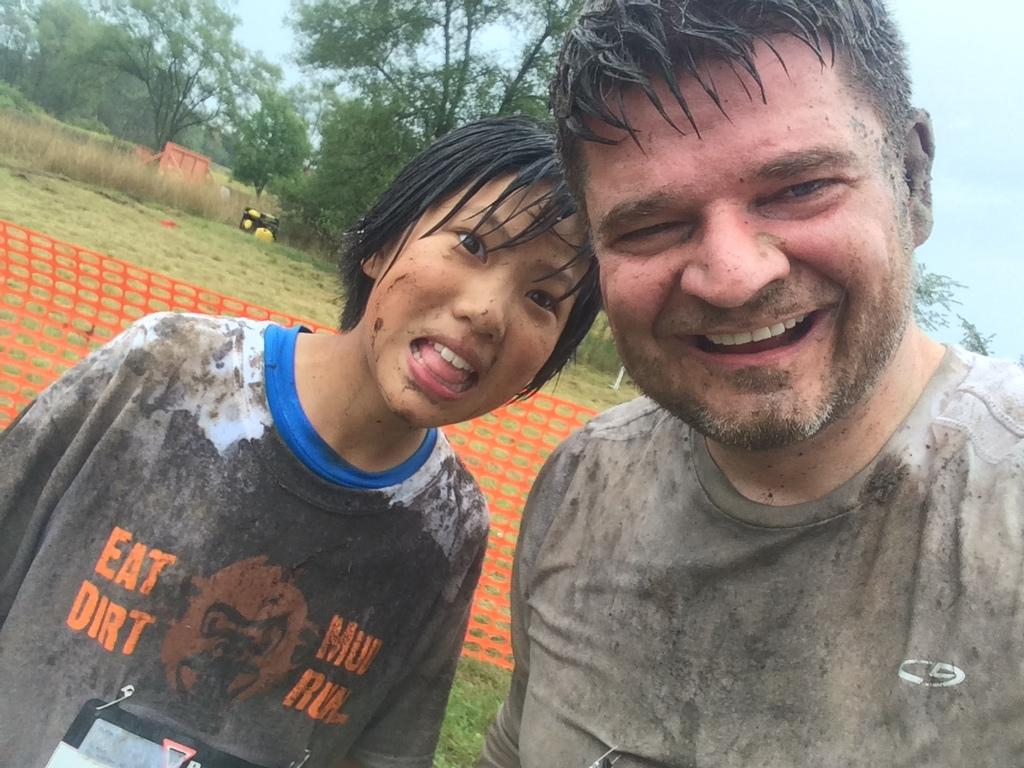How many people are in the image? There are two people in the image, a man and a woman. What are the man and woman doing in the image? Both the man and woman are standing on the grass. What can be seen in the background of the image? There is a net, trees, plants, and the sky visible in the background of the image. How many girls are playing in the quicksand in the image? There are no girls or quicksand present in the image. What type of knowledge can be gained from the image? The image does not convey any specific knowledge or information; it simply depicts a man and woman standing on the grass with a background of a net, trees, plants, and the sky. 